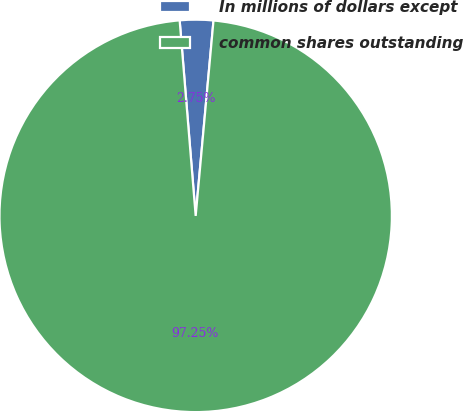Convert chart to OTSL. <chart><loc_0><loc_0><loc_500><loc_500><pie_chart><fcel>In millions of dollars except<fcel>common shares outstanding<nl><fcel>2.75%<fcel>97.25%<nl></chart> 